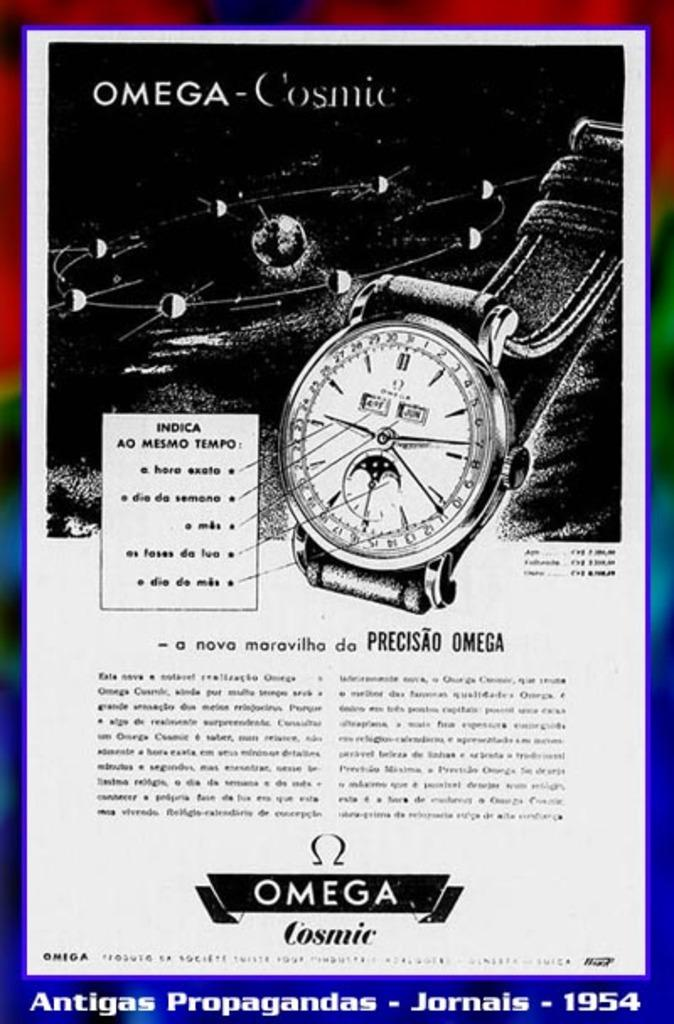Provide a one-sentence caption for the provided image. An advertisement about a watch that is the Omega Cosmic. 